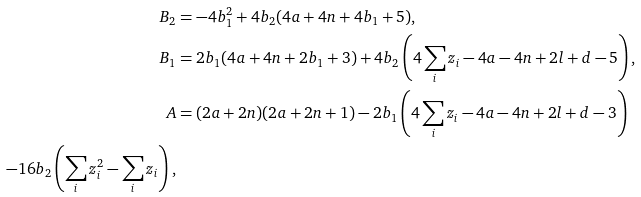<formula> <loc_0><loc_0><loc_500><loc_500>B _ { 2 } & = - 4 b _ { 1 } ^ { 2 } + 4 b _ { 2 } ( 4 a + 4 n + 4 b _ { 1 } + 5 ) , \\ B _ { 1 } & = 2 b _ { 1 } ( 4 a + 4 n + 2 b _ { 1 } + 3 ) + 4 b _ { 2 } \left ( 4 \sum _ { i } z _ { i } - 4 a - 4 n + 2 l + d - 5 \right ) , \\ A & = ( 2 a + 2 n ) ( 2 a + 2 n + 1 ) - 2 b _ { 1 } \left ( 4 \sum _ { i } z _ { i } - 4 a - 4 n + 2 l + d - 3 \right ) \\ - 1 6 b _ { 2 } \left ( \sum _ { i } z _ { i } ^ { 2 } - \sum _ { i } z _ { i } \right ) ,</formula> 